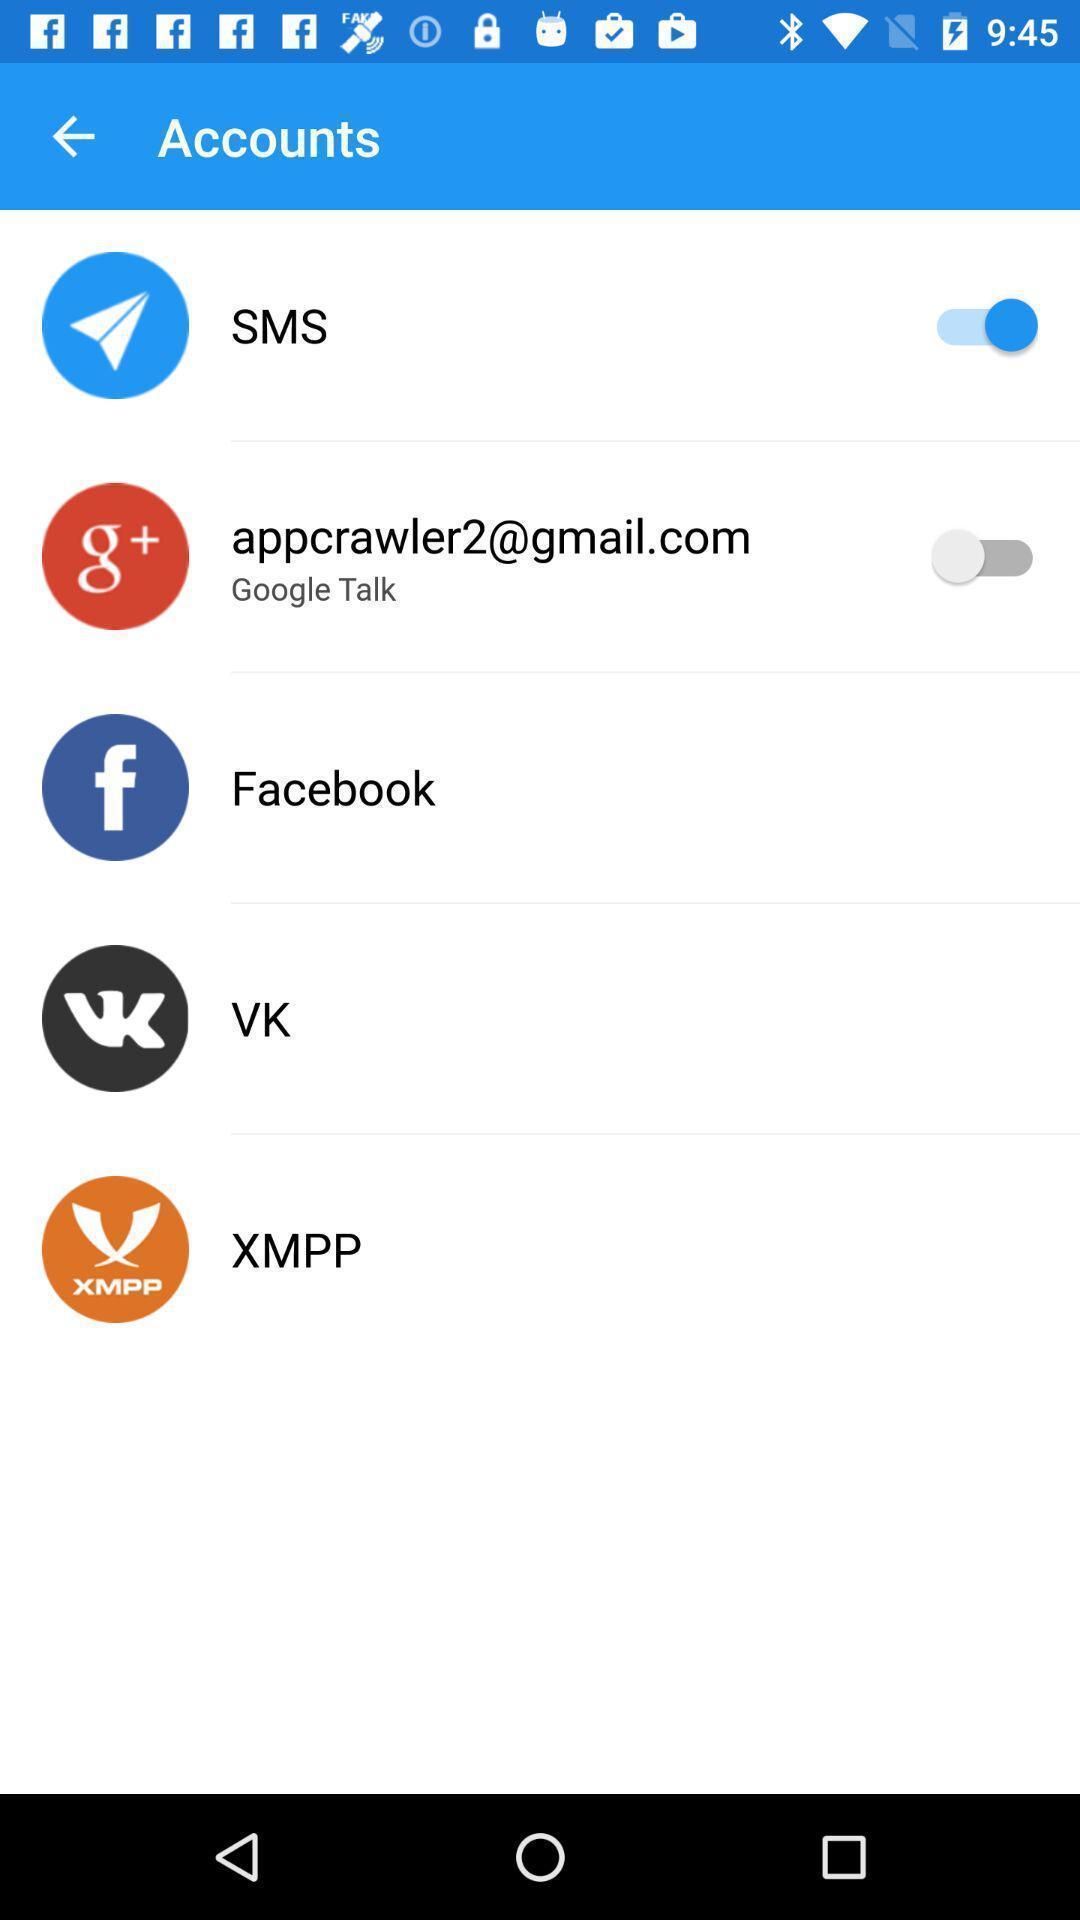Give me a narrative description of this picture. Page showing the different options in accounts. 